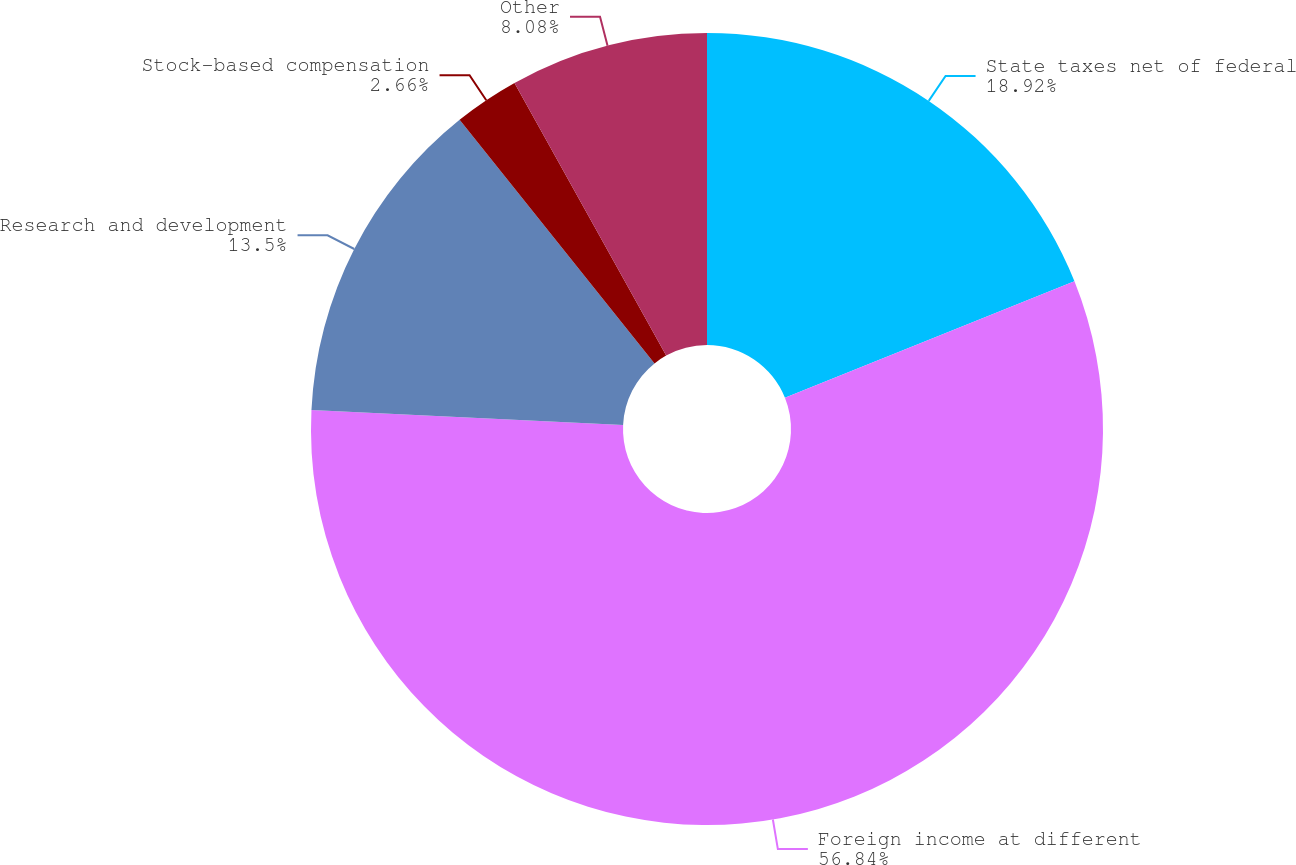Convert chart. <chart><loc_0><loc_0><loc_500><loc_500><pie_chart><fcel>State taxes net of federal<fcel>Foreign income at different<fcel>Research and development<fcel>Stock-based compensation<fcel>Other<nl><fcel>18.92%<fcel>56.84%<fcel>13.5%<fcel>2.66%<fcel>8.08%<nl></chart> 